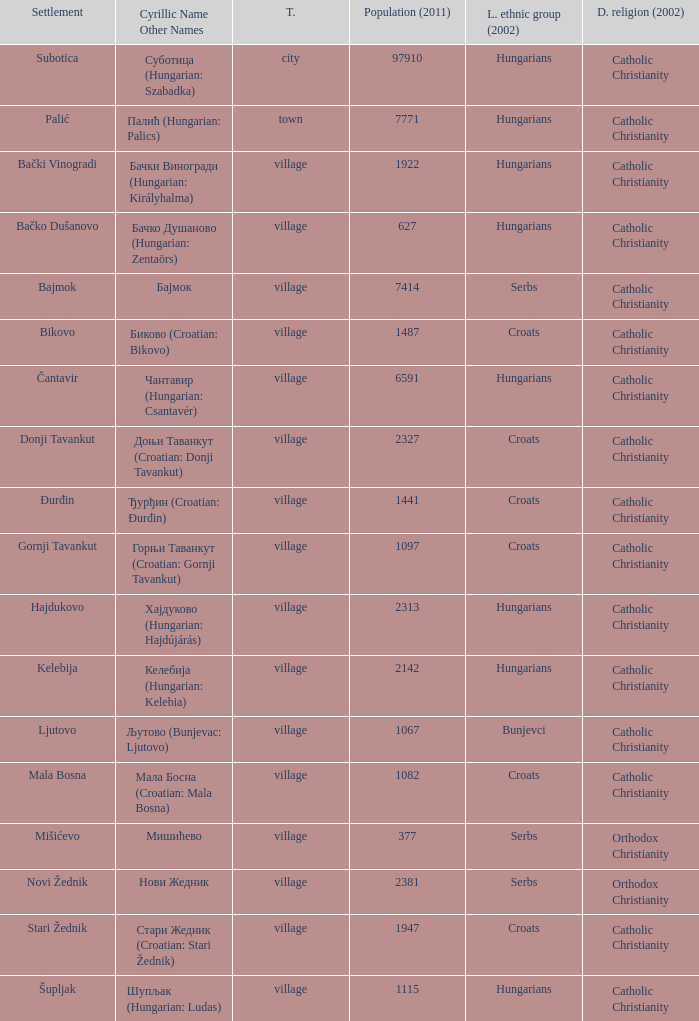What type of settlement has a population of 1441? Village. 